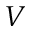Convert formula to latex. <formula><loc_0><loc_0><loc_500><loc_500>V</formula> 